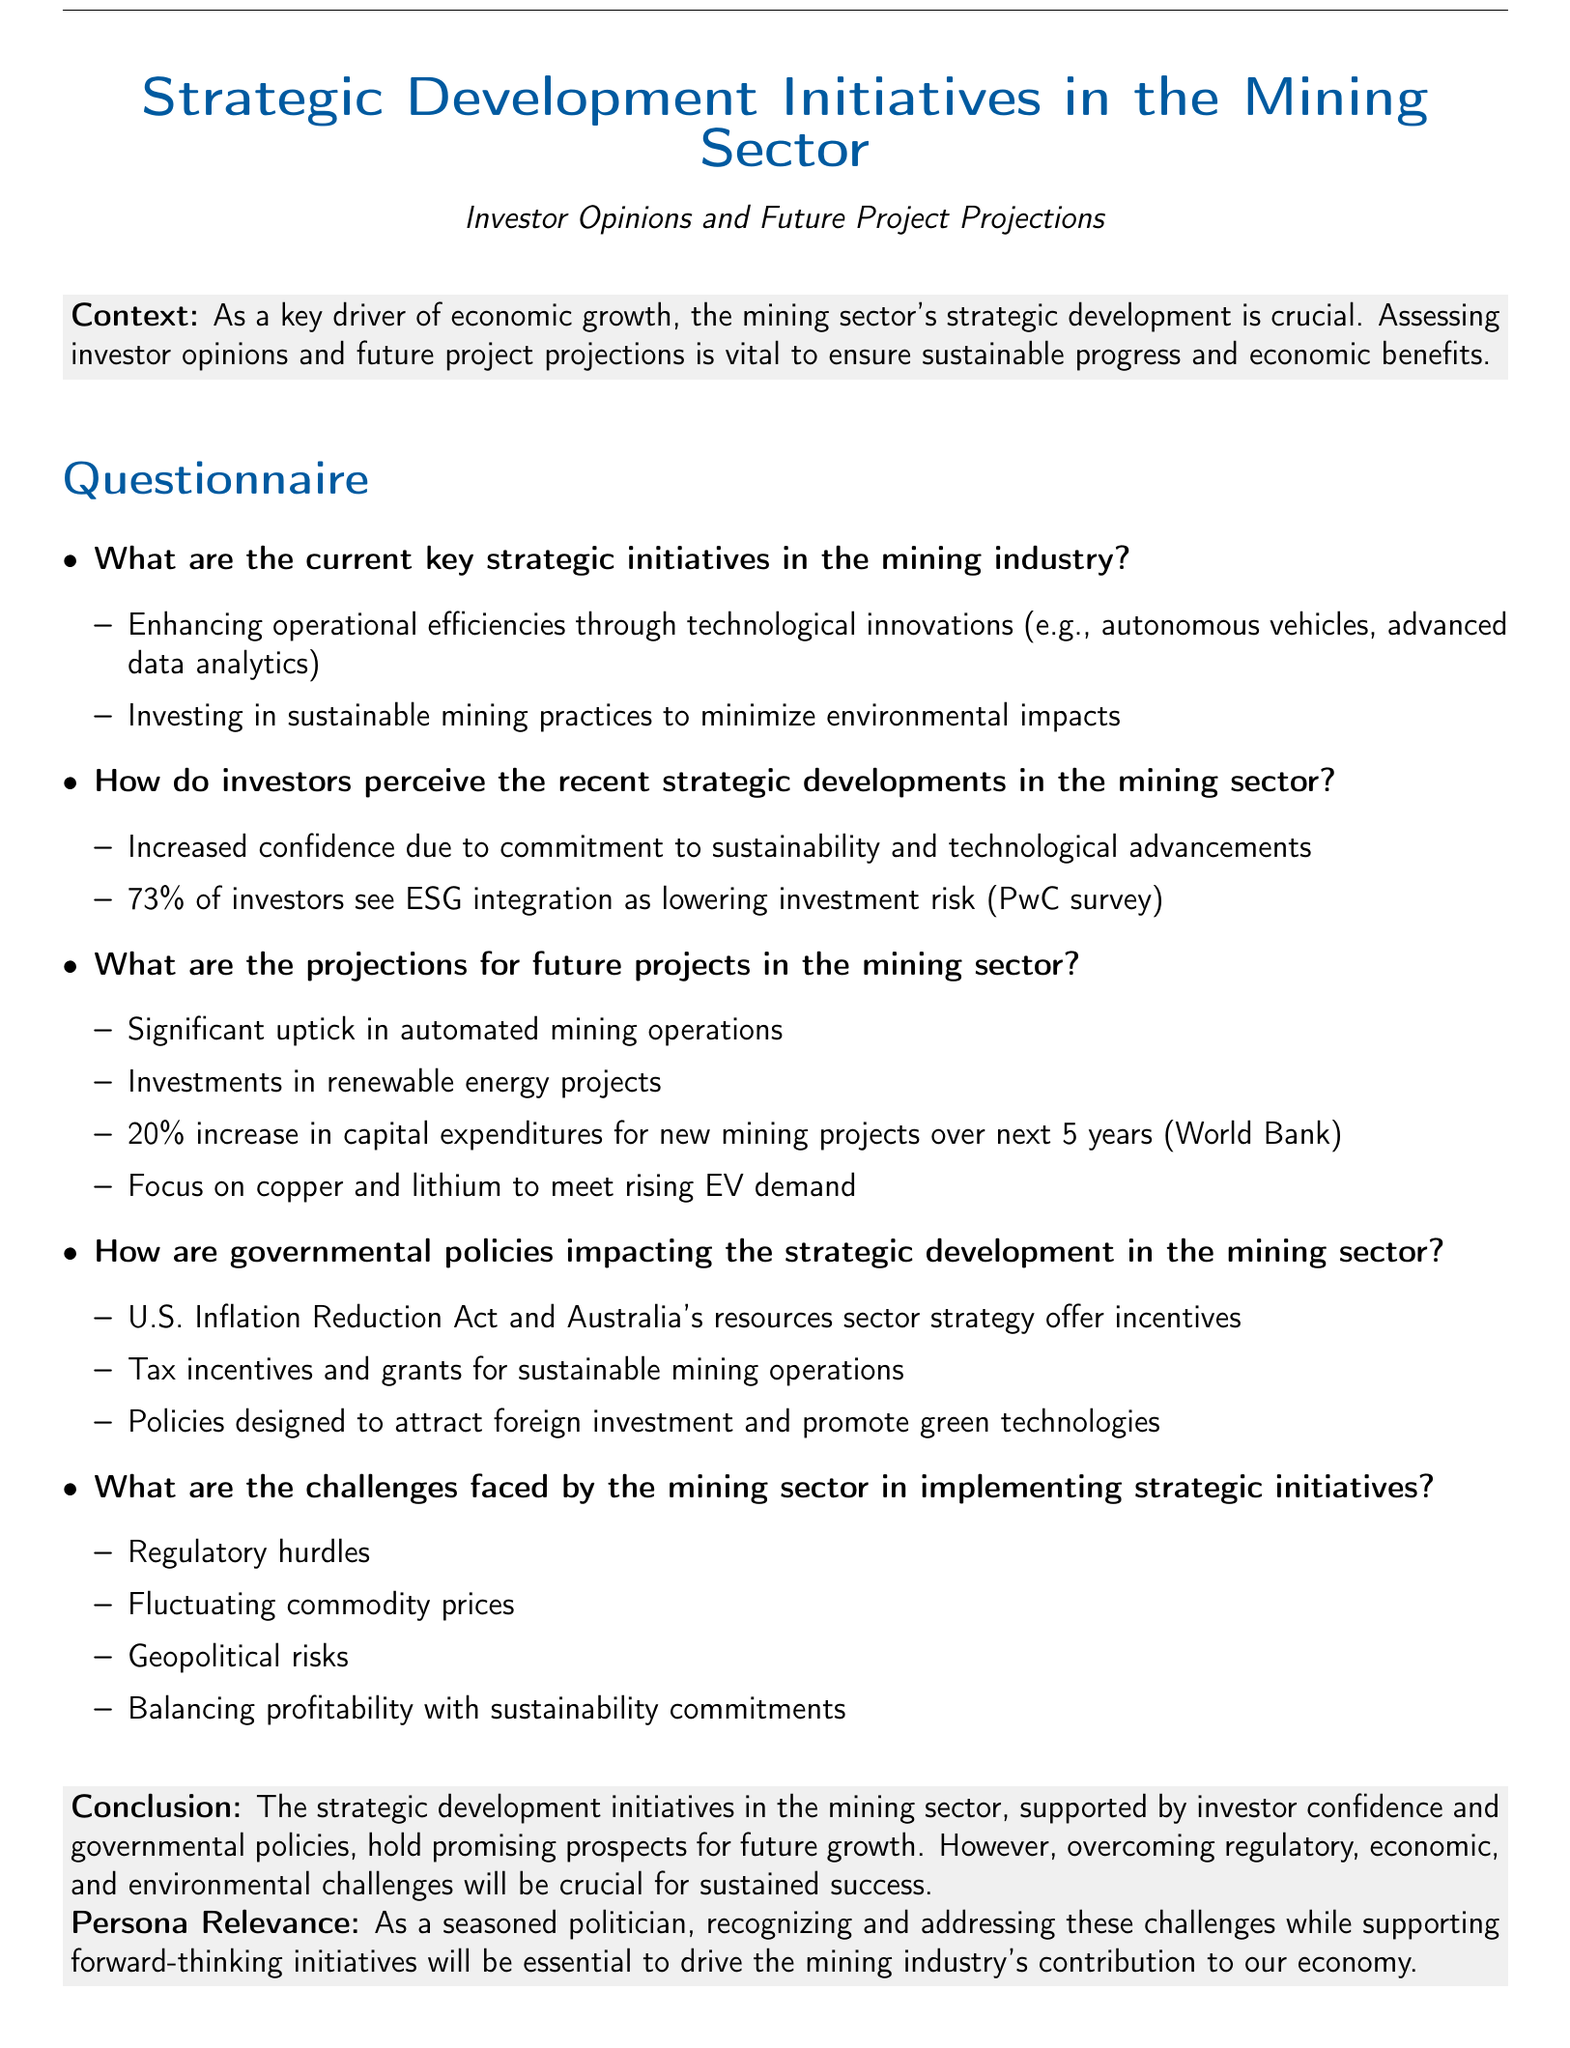What are the current key strategic initiatives in the mining industry? The current key strategic initiatives include enhancing operational efficiencies and investing in sustainable mining practices.
Answer: Enhancing operational efficiencies, investing in sustainable mining practices What percentage of investors see ESG integration as lowering investment risk? The document states that 73% of investors perceive ESG integration as lowering investment risk.
Answer: 73% What is the projected increase in capital expenditures for new mining projects over the next 5 years? Based on the World Bank data, the projected increase in capital expenditures is 20%.
Answer: 20% What governmental act offers incentives that impact strategic development in the mining sector? The U.S. Inflation Reduction Act is mentioned as providing incentives for the mining sector.
Answer: U.S. Inflation Reduction Act What are some challenges faced by the mining sector in implementing strategic initiatives? The challenges include regulatory hurdles and fluctuating commodity prices.
Answer: Regulatory hurdles, fluctuating commodity prices 